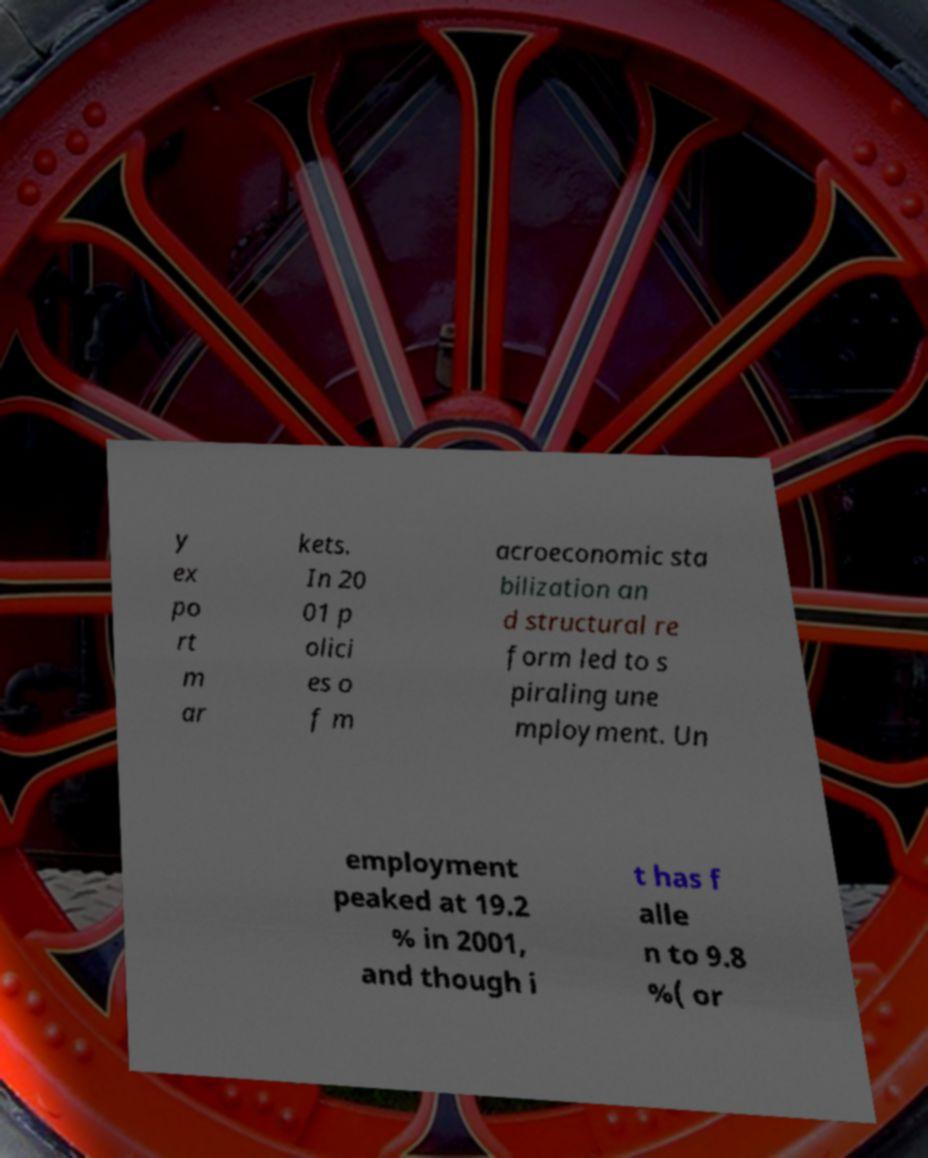There's text embedded in this image that I need extracted. Can you transcribe it verbatim? y ex po rt m ar kets. In 20 01 p olici es o f m acroeconomic sta bilization an d structural re form led to s piraling une mployment. Un employment peaked at 19.2 % in 2001, and though i t has f alle n to 9.8 %( or 